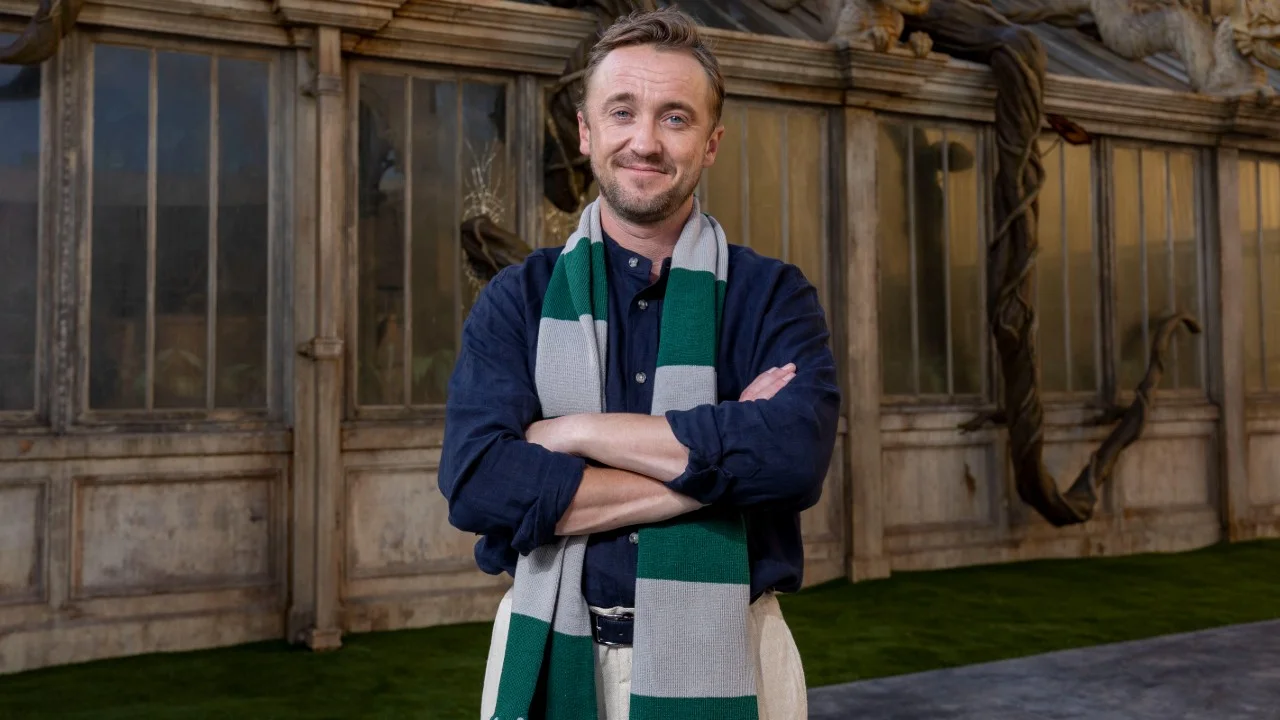Analyze the image in a comprehensive and detailed manner. The image captures a cheerful man standing in front of a large ornate window that features intricate detailing and statues, reminiscent of gothic architecture. He is dressed in a casual yet smart dark blue jacket over a striped sweater in colors of dark blue, green, and white, styled with a white collared shirt underneath. His arms are crossed, suggesting a relaxed but confident stance. This man has a friendly expression, with a light, welcoming smile. His outfit is complemented by a scarf that matches the sweater, adding to the smart-casual appearance. The environment gives a historical or possibly academic feel, possibly aligning with themes of heritage or learning. 